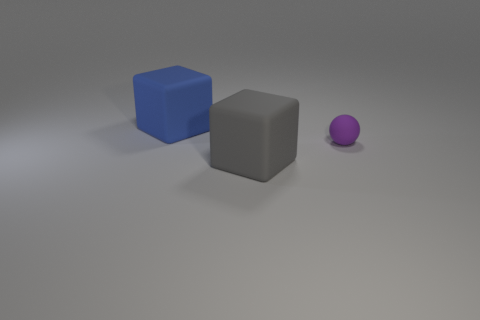Add 3 large gray matte objects. How many objects exist? 6 Subtract all spheres. How many objects are left? 2 Subtract all cyan cubes. Subtract all brown balls. How many cubes are left? 2 Add 3 big gray blocks. How many big gray blocks are left? 4 Add 2 tiny yellow cylinders. How many tiny yellow cylinders exist? 2 Subtract 1 gray blocks. How many objects are left? 2 Subtract all gray rubber cubes. Subtract all gray matte blocks. How many objects are left? 1 